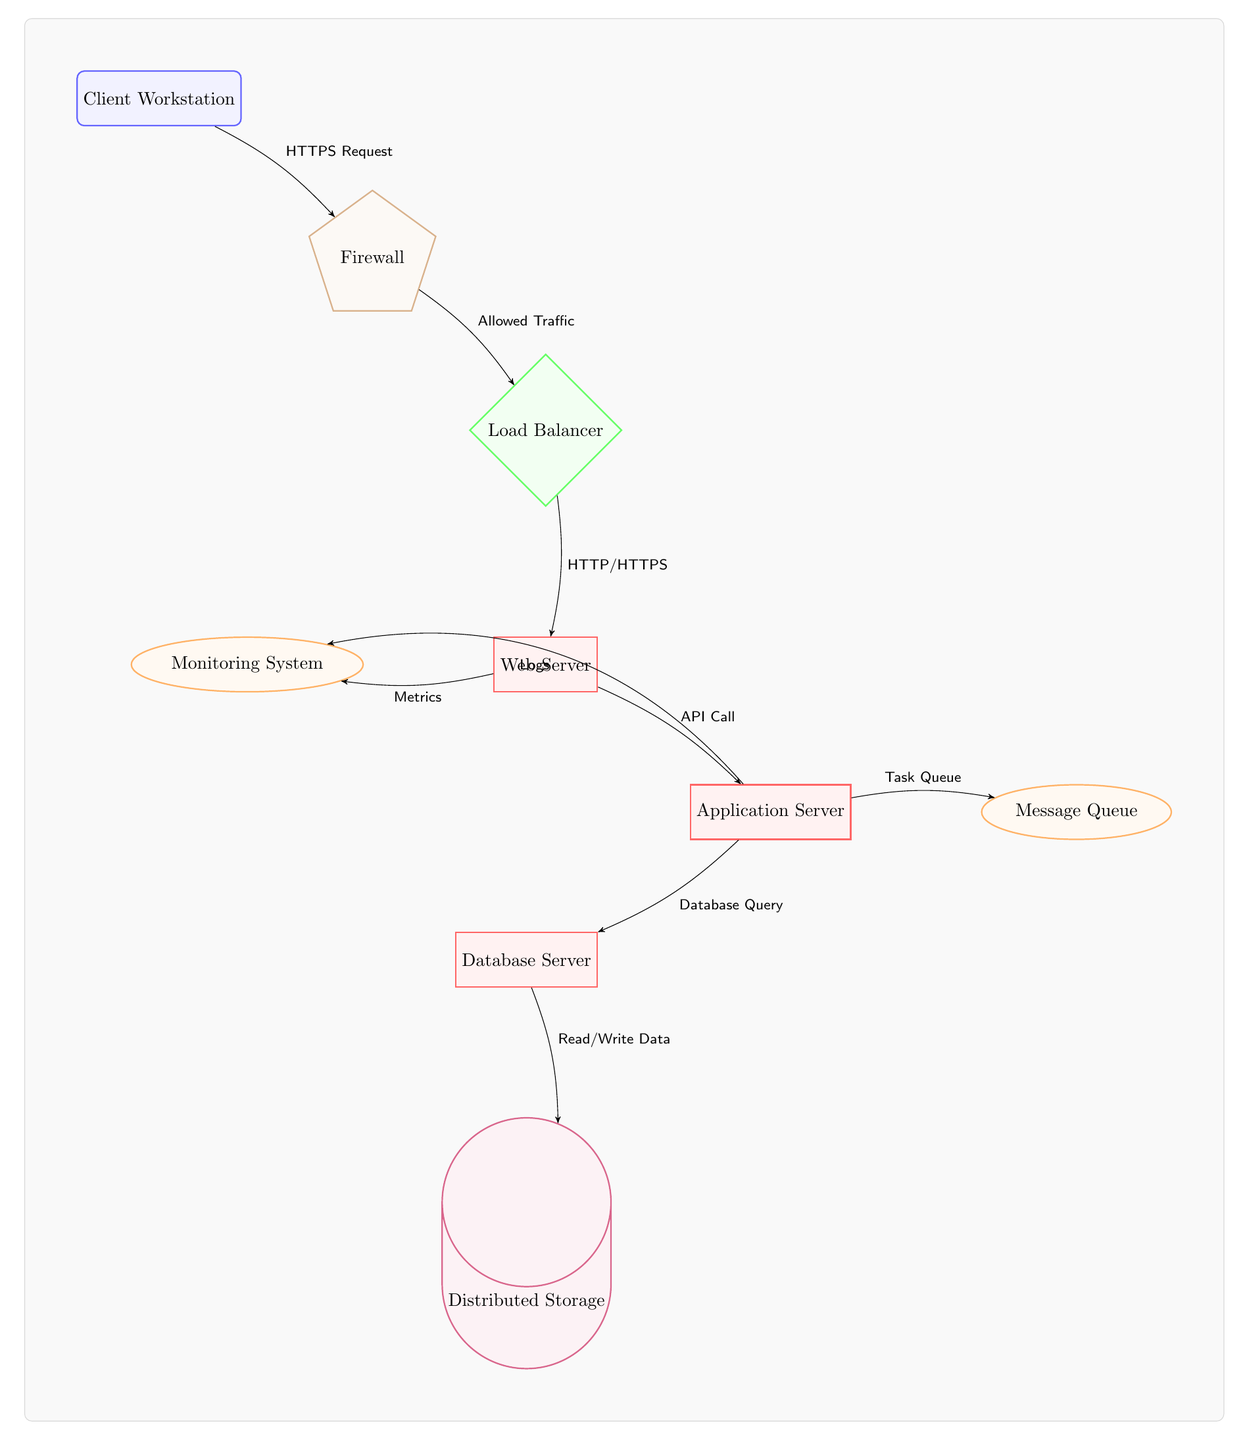What is the first node in the data flow? The first node is "Client Workstation," as it is the initial point from which the data flow begins in the diagram.
Answer: Client Workstation How many servers are represented in the diagram? There are three servers shown in the diagram: the Web Server, Application Server, and Database Server. Counting these nodes confirms that three distinct servers are included.
Answer: 3 What type of communication does the Load Balancer handle? The Load Balancer handles "HTTP/HTTPS" communication, as indicated by the arrow from the Load Balancer to the Web Server, labeled with these protocols.
Answer: HTTP/HTTPS What is the purpose of the Message Queue in the diagram? The Message Queue's role is to manage the "Task Queue," as shown in the diagram by the label on the arrow connecting the Application Server to the Message Queue.
Answer: Task Queue Which node sends metrics to the Monitoring System? The Web Server sends "Metrics" to the Monitoring System, as indicated by the labeled arrow pointing from the Web Server to the Monitoring System.
Answer: Metrics Which component receives Read/Write Data from the Database Server? The Distributed Storage component receives "Read/Write Data" from the Database Server, as evidenced by the arrow labeled with this interaction pointing to the Distributed Storage node.
Answer: Distributed Storage What type of security component is present in the diagram? The security component in the diagram is a "Firewall," presented as a node that governs the traffic between the Client Workstation and the Load Balancer.
Answer: Firewall How does the Application Server respond to database interactions? The Application Server responds to database interactions with a "Database Query," signified by the arrow from the Application Server to the Database Server, indicating the type of request made.
Answer: Database Query Which service is responsible for monitoring system performance? The "Monitoring System" is responsible for monitoring performance, as indicated by its connection to the Web Server labeled with "Metrics" being sent there.
Answer: Monitoring System 